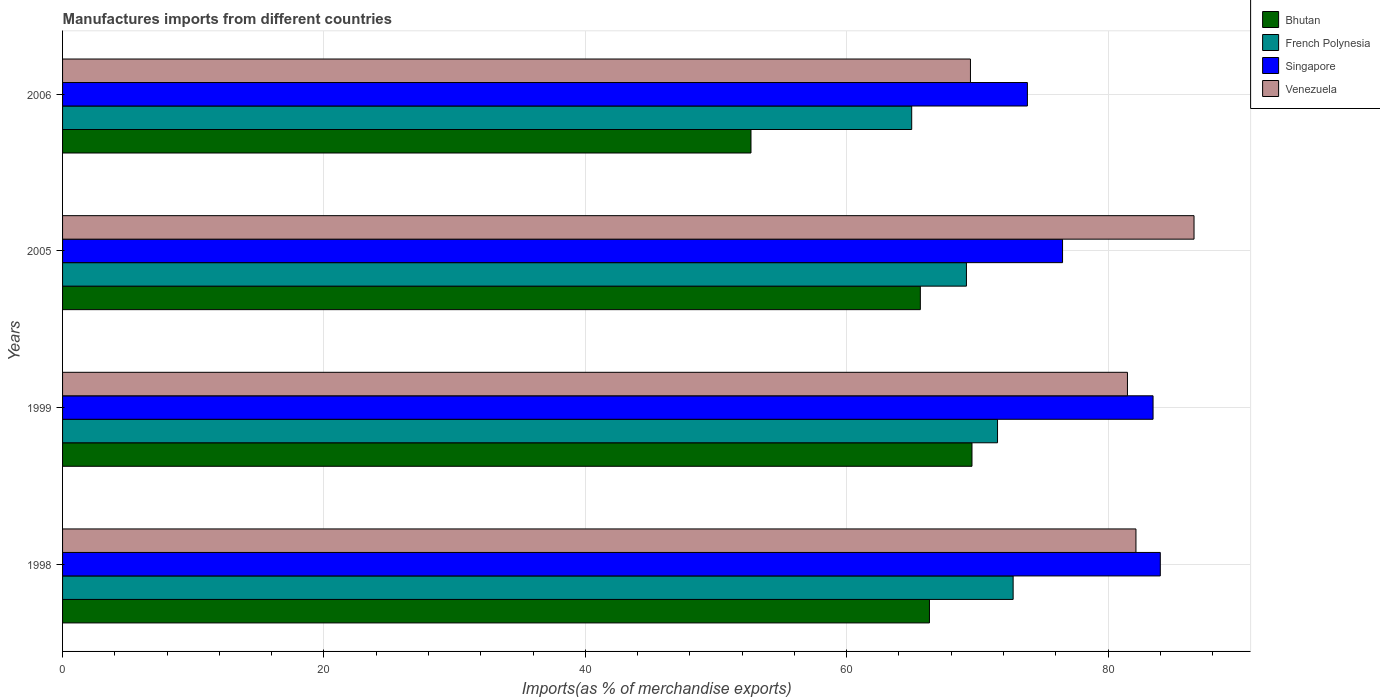Are the number of bars per tick equal to the number of legend labels?
Keep it short and to the point. Yes. What is the label of the 4th group of bars from the top?
Give a very brief answer. 1998. What is the percentage of imports to different countries in Venezuela in 2006?
Keep it short and to the point. 69.47. Across all years, what is the maximum percentage of imports to different countries in Singapore?
Offer a very short reply. 84. Across all years, what is the minimum percentage of imports to different countries in Bhutan?
Provide a succinct answer. 52.68. What is the total percentage of imports to different countries in Bhutan in the graph?
Offer a terse response. 254.25. What is the difference between the percentage of imports to different countries in French Polynesia in 1999 and that in 2005?
Provide a short and direct response. 2.38. What is the difference between the percentage of imports to different countries in Singapore in 2005 and the percentage of imports to different countries in Venezuela in 1999?
Offer a very short reply. -4.97. What is the average percentage of imports to different countries in Bhutan per year?
Provide a succinct answer. 63.56. In the year 2005, what is the difference between the percentage of imports to different countries in French Polynesia and percentage of imports to different countries in Venezuela?
Keep it short and to the point. -17.42. What is the ratio of the percentage of imports to different countries in Bhutan in 1998 to that in 2005?
Make the answer very short. 1.01. Is the difference between the percentage of imports to different countries in French Polynesia in 1999 and 2005 greater than the difference between the percentage of imports to different countries in Venezuela in 1999 and 2005?
Offer a terse response. Yes. What is the difference between the highest and the second highest percentage of imports to different countries in Venezuela?
Offer a very short reply. 4.44. What is the difference between the highest and the lowest percentage of imports to different countries in Bhutan?
Keep it short and to the point. 16.91. Is the sum of the percentage of imports to different countries in Singapore in 1999 and 2006 greater than the maximum percentage of imports to different countries in Bhutan across all years?
Offer a very short reply. Yes. What does the 3rd bar from the top in 1998 represents?
Keep it short and to the point. French Polynesia. What does the 2nd bar from the bottom in 2006 represents?
Provide a succinct answer. French Polynesia. Is it the case that in every year, the sum of the percentage of imports to different countries in Venezuela and percentage of imports to different countries in Bhutan is greater than the percentage of imports to different countries in French Polynesia?
Offer a terse response. Yes. How many bars are there?
Provide a short and direct response. 16. Are all the bars in the graph horizontal?
Your answer should be very brief. Yes. What is the difference between two consecutive major ticks on the X-axis?
Provide a succinct answer. 20. Does the graph contain grids?
Your response must be concise. Yes. How many legend labels are there?
Provide a short and direct response. 4. What is the title of the graph?
Your response must be concise. Manufactures imports from different countries. What is the label or title of the X-axis?
Keep it short and to the point. Imports(as % of merchandise exports). What is the label or title of the Y-axis?
Your response must be concise. Years. What is the Imports(as % of merchandise exports) of Bhutan in 1998?
Provide a short and direct response. 66.34. What is the Imports(as % of merchandise exports) of French Polynesia in 1998?
Provide a succinct answer. 72.74. What is the Imports(as % of merchandise exports) in Singapore in 1998?
Ensure brevity in your answer.  84. What is the Imports(as % of merchandise exports) of Venezuela in 1998?
Make the answer very short. 82.14. What is the Imports(as % of merchandise exports) in Bhutan in 1999?
Provide a succinct answer. 69.59. What is the Imports(as % of merchandise exports) of French Polynesia in 1999?
Keep it short and to the point. 71.55. What is the Imports(as % of merchandise exports) in Singapore in 1999?
Make the answer very short. 83.45. What is the Imports(as % of merchandise exports) of Venezuela in 1999?
Provide a short and direct response. 81.49. What is the Imports(as % of merchandise exports) of Bhutan in 2005?
Provide a short and direct response. 65.64. What is the Imports(as % of merchandise exports) of French Polynesia in 2005?
Offer a very short reply. 69.17. What is the Imports(as % of merchandise exports) in Singapore in 2005?
Provide a short and direct response. 76.52. What is the Imports(as % of merchandise exports) in Venezuela in 2005?
Offer a terse response. 86.58. What is the Imports(as % of merchandise exports) in Bhutan in 2006?
Ensure brevity in your answer.  52.68. What is the Imports(as % of merchandise exports) in French Polynesia in 2006?
Give a very brief answer. 64.98. What is the Imports(as % of merchandise exports) in Singapore in 2006?
Your answer should be very brief. 73.83. What is the Imports(as % of merchandise exports) of Venezuela in 2006?
Your answer should be compact. 69.47. Across all years, what is the maximum Imports(as % of merchandise exports) in Bhutan?
Give a very brief answer. 69.59. Across all years, what is the maximum Imports(as % of merchandise exports) of French Polynesia?
Ensure brevity in your answer.  72.74. Across all years, what is the maximum Imports(as % of merchandise exports) in Singapore?
Provide a short and direct response. 84. Across all years, what is the maximum Imports(as % of merchandise exports) of Venezuela?
Keep it short and to the point. 86.58. Across all years, what is the minimum Imports(as % of merchandise exports) of Bhutan?
Provide a short and direct response. 52.68. Across all years, what is the minimum Imports(as % of merchandise exports) in French Polynesia?
Your response must be concise. 64.98. Across all years, what is the minimum Imports(as % of merchandise exports) of Singapore?
Your answer should be compact. 73.83. Across all years, what is the minimum Imports(as % of merchandise exports) in Venezuela?
Provide a short and direct response. 69.47. What is the total Imports(as % of merchandise exports) in Bhutan in the graph?
Ensure brevity in your answer.  254.25. What is the total Imports(as % of merchandise exports) in French Polynesia in the graph?
Provide a succinct answer. 278.43. What is the total Imports(as % of merchandise exports) in Singapore in the graph?
Make the answer very short. 317.8. What is the total Imports(as % of merchandise exports) of Venezuela in the graph?
Provide a succinct answer. 319.68. What is the difference between the Imports(as % of merchandise exports) of Bhutan in 1998 and that in 1999?
Make the answer very short. -3.25. What is the difference between the Imports(as % of merchandise exports) of French Polynesia in 1998 and that in 1999?
Offer a terse response. 1.19. What is the difference between the Imports(as % of merchandise exports) of Singapore in 1998 and that in 1999?
Offer a terse response. 0.55. What is the difference between the Imports(as % of merchandise exports) of Venezuela in 1998 and that in 1999?
Your response must be concise. 0.65. What is the difference between the Imports(as % of merchandise exports) of Bhutan in 1998 and that in 2005?
Your answer should be very brief. 0.7. What is the difference between the Imports(as % of merchandise exports) in French Polynesia in 1998 and that in 2005?
Provide a short and direct response. 3.57. What is the difference between the Imports(as % of merchandise exports) of Singapore in 1998 and that in 2005?
Your answer should be very brief. 7.48. What is the difference between the Imports(as % of merchandise exports) of Venezuela in 1998 and that in 2005?
Your answer should be compact. -4.44. What is the difference between the Imports(as % of merchandise exports) of Bhutan in 1998 and that in 2006?
Make the answer very short. 13.66. What is the difference between the Imports(as % of merchandise exports) of French Polynesia in 1998 and that in 2006?
Offer a terse response. 7.76. What is the difference between the Imports(as % of merchandise exports) of Singapore in 1998 and that in 2006?
Your answer should be very brief. 10.17. What is the difference between the Imports(as % of merchandise exports) in Venezuela in 1998 and that in 2006?
Provide a succinct answer. 12.66. What is the difference between the Imports(as % of merchandise exports) of Bhutan in 1999 and that in 2005?
Your answer should be compact. 3.95. What is the difference between the Imports(as % of merchandise exports) of French Polynesia in 1999 and that in 2005?
Your response must be concise. 2.38. What is the difference between the Imports(as % of merchandise exports) in Singapore in 1999 and that in 2005?
Offer a terse response. 6.93. What is the difference between the Imports(as % of merchandise exports) in Venezuela in 1999 and that in 2005?
Give a very brief answer. -5.09. What is the difference between the Imports(as % of merchandise exports) of Bhutan in 1999 and that in 2006?
Offer a very short reply. 16.91. What is the difference between the Imports(as % of merchandise exports) of French Polynesia in 1999 and that in 2006?
Provide a short and direct response. 6.57. What is the difference between the Imports(as % of merchandise exports) in Singapore in 1999 and that in 2006?
Keep it short and to the point. 9.62. What is the difference between the Imports(as % of merchandise exports) in Venezuela in 1999 and that in 2006?
Make the answer very short. 12.01. What is the difference between the Imports(as % of merchandise exports) of Bhutan in 2005 and that in 2006?
Provide a short and direct response. 12.96. What is the difference between the Imports(as % of merchandise exports) of French Polynesia in 2005 and that in 2006?
Provide a succinct answer. 4.19. What is the difference between the Imports(as % of merchandise exports) of Singapore in 2005 and that in 2006?
Your answer should be compact. 2.69. What is the difference between the Imports(as % of merchandise exports) of Venezuela in 2005 and that in 2006?
Give a very brief answer. 17.11. What is the difference between the Imports(as % of merchandise exports) in Bhutan in 1998 and the Imports(as % of merchandise exports) in French Polynesia in 1999?
Make the answer very short. -5.21. What is the difference between the Imports(as % of merchandise exports) in Bhutan in 1998 and the Imports(as % of merchandise exports) in Singapore in 1999?
Keep it short and to the point. -17.11. What is the difference between the Imports(as % of merchandise exports) in Bhutan in 1998 and the Imports(as % of merchandise exports) in Venezuela in 1999?
Offer a very short reply. -15.15. What is the difference between the Imports(as % of merchandise exports) of French Polynesia in 1998 and the Imports(as % of merchandise exports) of Singapore in 1999?
Your answer should be compact. -10.71. What is the difference between the Imports(as % of merchandise exports) in French Polynesia in 1998 and the Imports(as % of merchandise exports) in Venezuela in 1999?
Give a very brief answer. -8.75. What is the difference between the Imports(as % of merchandise exports) in Singapore in 1998 and the Imports(as % of merchandise exports) in Venezuela in 1999?
Keep it short and to the point. 2.51. What is the difference between the Imports(as % of merchandise exports) in Bhutan in 1998 and the Imports(as % of merchandise exports) in French Polynesia in 2005?
Offer a terse response. -2.83. What is the difference between the Imports(as % of merchandise exports) in Bhutan in 1998 and the Imports(as % of merchandise exports) in Singapore in 2005?
Give a very brief answer. -10.18. What is the difference between the Imports(as % of merchandise exports) in Bhutan in 1998 and the Imports(as % of merchandise exports) in Venezuela in 2005?
Your response must be concise. -20.25. What is the difference between the Imports(as % of merchandise exports) in French Polynesia in 1998 and the Imports(as % of merchandise exports) in Singapore in 2005?
Give a very brief answer. -3.78. What is the difference between the Imports(as % of merchandise exports) of French Polynesia in 1998 and the Imports(as % of merchandise exports) of Venezuela in 2005?
Your answer should be compact. -13.84. What is the difference between the Imports(as % of merchandise exports) in Singapore in 1998 and the Imports(as % of merchandise exports) in Venezuela in 2005?
Give a very brief answer. -2.58. What is the difference between the Imports(as % of merchandise exports) of Bhutan in 1998 and the Imports(as % of merchandise exports) of French Polynesia in 2006?
Ensure brevity in your answer.  1.36. What is the difference between the Imports(as % of merchandise exports) of Bhutan in 1998 and the Imports(as % of merchandise exports) of Singapore in 2006?
Your answer should be very brief. -7.49. What is the difference between the Imports(as % of merchandise exports) of Bhutan in 1998 and the Imports(as % of merchandise exports) of Venezuela in 2006?
Offer a very short reply. -3.14. What is the difference between the Imports(as % of merchandise exports) of French Polynesia in 1998 and the Imports(as % of merchandise exports) of Singapore in 2006?
Your response must be concise. -1.09. What is the difference between the Imports(as % of merchandise exports) in French Polynesia in 1998 and the Imports(as % of merchandise exports) in Venezuela in 2006?
Your response must be concise. 3.27. What is the difference between the Imports(as % of merchandise exports) of Singapore in 1998 and the Imports(as % of merchandise exports) of Venezuela in 2006?
Your answer should be compact. 14.53. What is the difference between the Imports(as % of merchandise exports) of Bhutan in 1999 and the Imports(as % of merchandise exports) of French Polynesia in 2005?
Your answer should be very brief. 0.43. What is the difference between the Imports(as % of merchandise exports) of Bhutan in 1999 and the Imports(as % of merchandise exports) of Singapore in 2005?
Give a very brief answer. -6.93. What is the difference between the Imports(as % of merchandise exports) in Bhutan in 1999 and the Imports(as % of merchandise exports) in Venezuela in 2005?
Ensure brevity in your answer.  -16.99. What is the difference between the Imports(as % of merchandise exports) in French Polynesia in 1999 and the Imports(as % of merchandise exports) in Singapore in 2005?
Keep it short and to the point. -4.97. What is the difference between the Imports(as % of merchandise exports) in French Polynesia in 1999 and the Imports(as % of merchandise exports) in Venezuela in 2005?
Your answer should be compact. -15.04. What is the difference between the Imports(as % of merchandise exports) in Singapore in 1999 and the Imports(as % of merchandise exports) in Venezuela in 2005?
Ensure brevity in your answer.  -3.13. What is the difference between the Imports(as % of merchandise exports) in Bhutan in 1999 and the Imports(as % of merchandise exports) in French Polynesia in 2006?
Your response must be concise. 4.61. What is the difference between the Imports(as % of merchandise exports) in Bhutan in 1999 and the Imports(as % of merchandise exports) in Singapore in 2006?
Provide a succinct answer. -4.24. What is the difference between the Imports(as % of merchandise exports) of Bhutan in 1999 and the Imports(as % of merchandise exports) of Venezuela in 2006?
Your answer should be very brief. 0.12. What is the difference between the Imports(as % of merchandise exports) in French Polynesia in 1999 and the Imports(as % of merchandise exports) in Singapore in 2006?
Provide a succinct answer. -2.29. What is the difference between the Imports(as % of merchandise exports) of French Polynesia in 1999 and the Imports(as % of merchandise exports) of Venezuela in 2006?
Ensure brevity in your answer.  2.07. What is the difference between the Imports(as % of merchandise exports) in Singapore in 1999 and the Imports(as % of merchandise exports) in Venezuela in 2006?
Offer a very short reply. 13.97. What is the difference between the Imports(as % of merchandise exports) of Bhutan in 2005 and the Imports(as % of merchandise exports) of French Polynesia in 2006?
Your answer should be compact. 0.66. What is the difference between the Imports(as % of merchandise exports) in Bhutan in 2005 and the Imports(as % of merchandise exports) in Singapore in 2006?
Ensure brevity in your answer.  -8.19. What is the difference between the Imports(as % of merchandise exports) of Bhutan in 2005 and the Imports(as % of merchandise exports) of Venezuela in 2006?
Your answer should be very brief. -3.84. What is the difference between the Imports(as % of merchandise exports) in French Polynesia in 2005 and the Imports(as % of merchandise exports) in Singapore in 2006?
Your answer should be compact. -4.67. What is the difference between the Imports(as % of merchandise exports) in French Polynesia in 2005 and the Imports(as % of merchandise exports) in Venezuela in 2006?
Make the answer very short. -0.31. What is the difference between the Imports(as % of merchandise exports) in Singapore in 2005 and the Imports(as % of merchandise exports) in Venezuela in 2006?
Provide a succinct answer. 7.05. What is the average Imports(as % of merchandise exports) in Bhutan per year?
Make the answer very short. 63.56. What is the average Imports(as % of merchandise exports) in French Polynesia per year?
Provide a succinct answer. 69.61. What is the average Imports(as % of merchandise exports) in Singapore per year?
Provide a short and direct response. 79.45. What is the average Imports(as % of merchandise exports) in Venezuela per year?
Make the answer very short. 79.92. In the year 1998, what is the difference between the Imports(as % of merchandise exports) of Bhutan and Imports(as % of merchandise exports) of French Polynesia?
Provide a succinct answer. -6.4. In the year 1998, what is the difference between the Imports(as % of merchandise exports) in Bhutan and Imports(as % of merchandise exports) in Singapore?
Keep it short and to the point. -17.66. In the year 1998, what is the difference between the Imports(as % of merchandise exports) in Bhutan and Imports(as % of merchandise exports) in Venezuela?
Keep it short and to the point. -15.8. In the year 1998, what is the difference between the Imports(as % of merchandise exports) of French Polynesia and Imports(as % of merchandise exports) of Singapore?
Provide a short and direct response. -11.26. In the year 1998, what is the difference between the Imports(as % of merchandise exports) of French Polynesia and Imports(as % of merchandise exports) of Venezuela?
Offer a terse response. -9.4. In the year 1998, what is the difference between the Imports(as % of merchandise exports) of Singapore and Imports(as % of merchandise exports) of Venezuela?
Make the answer very short. 1.86. In the year 1999, what is the difference between the Imports(as % of merchandise exports) of Bhutan and Imports(as % of merchandise exports) of French Polynesia?
Keep it short and to the point. -1.95. In the year 1999, what is the difference between the Imports(as % of merchandise exports) in Bhutan and Imports(as % of merchandise exports) in Singapore?
Make the answer very short. -13.86. In the year 1999, what is the difference between the Imports(as % of merchandise exports) in Bhutan and Imports(as % of merchandise exports) in Venezuela?
Ensure brevity in your answer.  -11.9. In the year 1999, what is the difference between the Imports(as % of merchandise exports) in French Polynesia and Imports(as % of merchandise exports) in Singapore?
Offer a very short reply. -11.9. In the year 1999, what is the difference between the Imports(as % of merchandise exports) of French Polynesia and Imports(as % of merchandise exports) of Venezuela?
Offer a terse response. -9.94. In the year 1999, what is the difference between the Imports(as % of merchandise exports) of Singapore and Imports(as % of merchandise exports) of Venezuela?
Offer a terse response. 1.96. In the year 2005, what is the difference between the Imports(as % of merchandise exports) of Bhutan and Imports(as % of merchandise exports) of French Polynesia?
Your answer should be compact. -3.53. In the year 2005, what is the difference between the Imports(as % of merchandise exports) in Bhutan and Imports(as % of merchandise exports) in Singapore?
Ensure brevity in your answer.  -10.88. In the year 2005, what is the difference between the Imports(as % of merchandise exports) of Bhutan and Imports(as % of merchandise exports) of Venezuela?
Ensure brevity in your answer.  -20.94. In the year 2005, what is the difference between the Imports(as % of merchandise exports) in French Polynesia and Imports(as % of merchandise exports) in Singapore?
Your response must be concise. -7.35. In the year 2005, what is the difference between the Imports(as % of merchandise exports) in French Polynesia and Imports(as % of merchandise exports) in Venezuela?
Provide a succinct answer. -17.42. In the year 2005, what is the difference between the Imports(as % of merchandise exports) in Singapore and Imports(as % of merchandise exports) in Venezuela?
Your response must be concise. -10.06. In the year 2006, what is the difference between the Imports(as % of merchandise exports) in Bhutan and Imports(as % of merchandise exports) in French Polynesia?
Give a very brief answer. -12.3. In the year 2006, what is the difference between the Imports(as % of merchandise exports) of Bhutan and Imports(as % of merchandise exports) of Singapore?
Ensure brevity in your answer.  -21.15. In the year 2006, what is the difference between the Imports(as % of merchandise exports) in Bhutan and Imports(as % of merchandise exports) in Venezuela?
Offer a terse response. -16.79. In the year 2006, what is the difference between the Imports(as % of merchandise exports) in French Polynesia and Imports(as % of merchandise exports) in Singapore?
Your answer should be very brief. -8.85. In the year 2006, what is the difference between the Imports(as % of merchandise exports) in French Polynesia and Imports(as % of merchandise exports) in Venezuela?
Give a very brief answer. -4.5. In the year 2006, what is the difference between the Imports(as % of merchandise exports) in Singapore and Imports(as % of merchandise exports) in Venezuela?
Keep it short and to the point. 4.36. What is the ratio of the Imports(as % of merchandise exports) of Bhutan in 1998 to that in 1999?
Your answer should be very brief. 0.95. What is the ratio of the Imports(as % of merchandise exports) of French Polynesia in 1998 to that in 1999?
Your response must be concise. 1.02. What is the ratio of the Imports(as % of merchandise exports) of Singapore in 1998 to that in 1999?
Offer a terse response. 1.01. What is the ratio of the Imports(as % of merchandise exports) in Bhutan in 1998 to that in 2005?
Make the answer very short. 1.01. What is the ratio of the Imports(as % of merchandise exports) of French Polynesia in 1998 to that in 2005?
Ensure brevity in your answer.  1.05. What is the ratio of the Imports(as % of merchandise exports) in Singapore in 1998 to that in 2005?
Give a very brief answer. 1.1. What is the ratio of the Imports(as % of merchandise exports) of Venezuela in 1998 to that in 2005?
Your response must be concise. 0.95. What is the ratio of the Imports(as % of merchandise exports) of Bhutan in 1998 to that in 2006?
Provide a succinct answer. 1.26. What is the ratio of the Imports(as % of merchandise exports) of French Polynesia in 1998 to that in 2006?
Provide a short and direct response. 1.12. What is the ratio of the Imports(as % of merchandise exports) of Singapore in 1998 to that in 2006?
Your answer should be compact. 1.14. What is the ratio of the Imports(as % of merchandise exports) of Venezuela in 1998 to that in 2006?
Offer a terse response. 1.18. What is the ratio of the Imports(as % of merchandise exports) in Bhutan in 1999 to that in 2005?
Give a very brief answer. 1.06. What is the ratio of the Imports(as % of merchandise exports) of French Polynesia in 1999 to that in 2005?
Make the answer very short. 1.03. What is the ratio of the Imports(as % of merchandise exports) in Singapore in 1999 to that in 2005?
Make the answer very short. 1.09. What is the ratio of the Imports(as % of merchandise exports) of Venezuela in 1999 to that in 2005?
Your answer should be very brief. 0.94. What is the ratio of the Imports(as % of merchandise exports) of Bhutan in 1999 to that in 2006?
Provide a short and direct response. 1.32. What is the ratio of the Imports(as % of merchandise exports) of French Polynesia in 1999 to that in 2006?
Provide a succinct answer. 1.1. What is the ratio of the Imports(as % of merchandise exports) of Singapore in 1999 to that in 2006?
Provide a short and direct response. 1.13. What is the ratio of the Imports(as % of merchandise exports) of Venezuela in 1999 to that in 2006?
Make the answer very short. 1.17. What is the ratio of the Imports(as % of merchandise exports) of Bhutan in 2005 to that in 2006?
Provide a succinct answer. 1.25. What is the ratio of the Imports(as % of merchandise exports) in French Polynesia in 2005 to that in 2006?
Your response must be concise. 1.06. What is the ratio of the Imports(as % of merchandise exports) of Singapore in 2005 to that in 2006?
Your response must be concise. 1.04. What is the ratio of the Imports(as % of merchandise exports) of Venezuela in 2005 to that in 2006?
Give a very brief answer. 1.25. What is the difference between the highest and the second highest Imports(as % of merchandise exports) of Bhutan?
Ensure brevity in your answer.  3.25. What is the difference between the highest and the second highest Imports(as % of merchandise exports) in French Polynesia?
Make the answer very short. 1.19. What is the difference between the highest and the second highest Imports(as % of merchandise exports) of Singapore?
Provide a succinct answer. 0.55. What is the difference between the highest and the second highest Imports(as % of merchandise exports) in Venezuela?
Offer a very short reply. 4.44. What is the difference between the highest and the lowest Imports(as % of merchandise exports) in Bhutan?
Give a very brief answer. 16.91. What is the difference between the highest and the lowest Imports(as % of merchandise exports) of French Polynesia?
Your answer should be very brief. 7.76. What is the difference between the highest and the lowest Imports(as % of merchandise exports) in Singapore?
Your answer should be very brief. 10.17. What is the difference between the highest and the lowest Imports(as % of merchandise exports) in Venezuela?
Your answer should be compact. 17.11. 